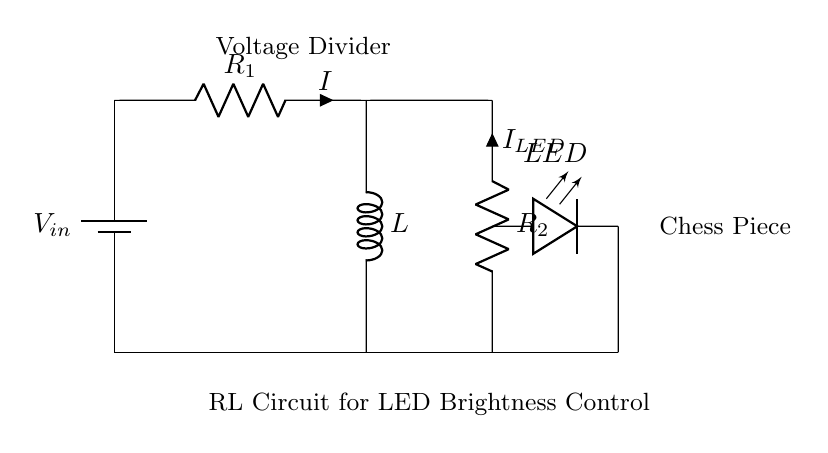What is the voltage source in this circuit? The circuit diagram shows a battery labeled as \(V_{in}\) at the top. This indicates that the voltage source powering the circuit is the battery denoted by \(V_{in}\).
Answer: \(V_{in}\) What type of components are used in this circuit? The circuit consists of a battery, resistors, an inductor, and a LED as noted in the labels on the components. These are standard components found in an RL circuit used for adjusting brightness.
Answer: Resistor, inductor, LED, battery What is the purpose of the resistors in this circuit? The resistors \(R_1\) and \(R_2\) are part of a voltage divider configuration that is used to adjust the current flowing through the LED, thereby controlling its brightness.
Answer: Adjust LED brightness How does the inductor affect the circuit operation? The inductor \(L\) in the circuit provides inductance which can affect the flow of current, particularly by resisting changes in current and smoothing out fluctuations. This helps in maintaining a more stable current through the LED.
Answer: Provides stability What is the current \(I_{LED}\) in the LED branch? The current \(I_{LED}\) can be inferred based on the configuration of the resistors in relation to the voltage applied and circuit laws, primarily Ohm's Law and the division of current between the branches. Calculation may be needed for exact values.
Answer: Dependent on \(R_2\) and \(V_{in}\) Which component acts as a voltage divider in this circuit? The voltage divider is a combination of \(R_1\) and \(R_2\) that divides the input voltage \(V_{in}\) into smaller voltages suitable for the LED, thus allowing control of its brightness.
Answer: \(R_1\) and \(R_2\) What happens to the LED brightness if \(R_2\) is increased? Increasing \(R_2\) reduces the current flowing through the LED, given the fixed \(V_{in}\), which will result in dimmer brightness since \(I_{LED}\) is less.
Answer: Brightness decreases 